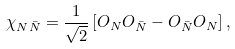<formula> <loc_0><loc_0><loc_500><loc_500>\chi _ { N \bar { N } } = \frac { 1 } { \sqrt { 2 } } \left [ O _ { N } O _ { \bar { N } } - O _ { \bar { N } } O _ { N } \right ] ,</formula> 